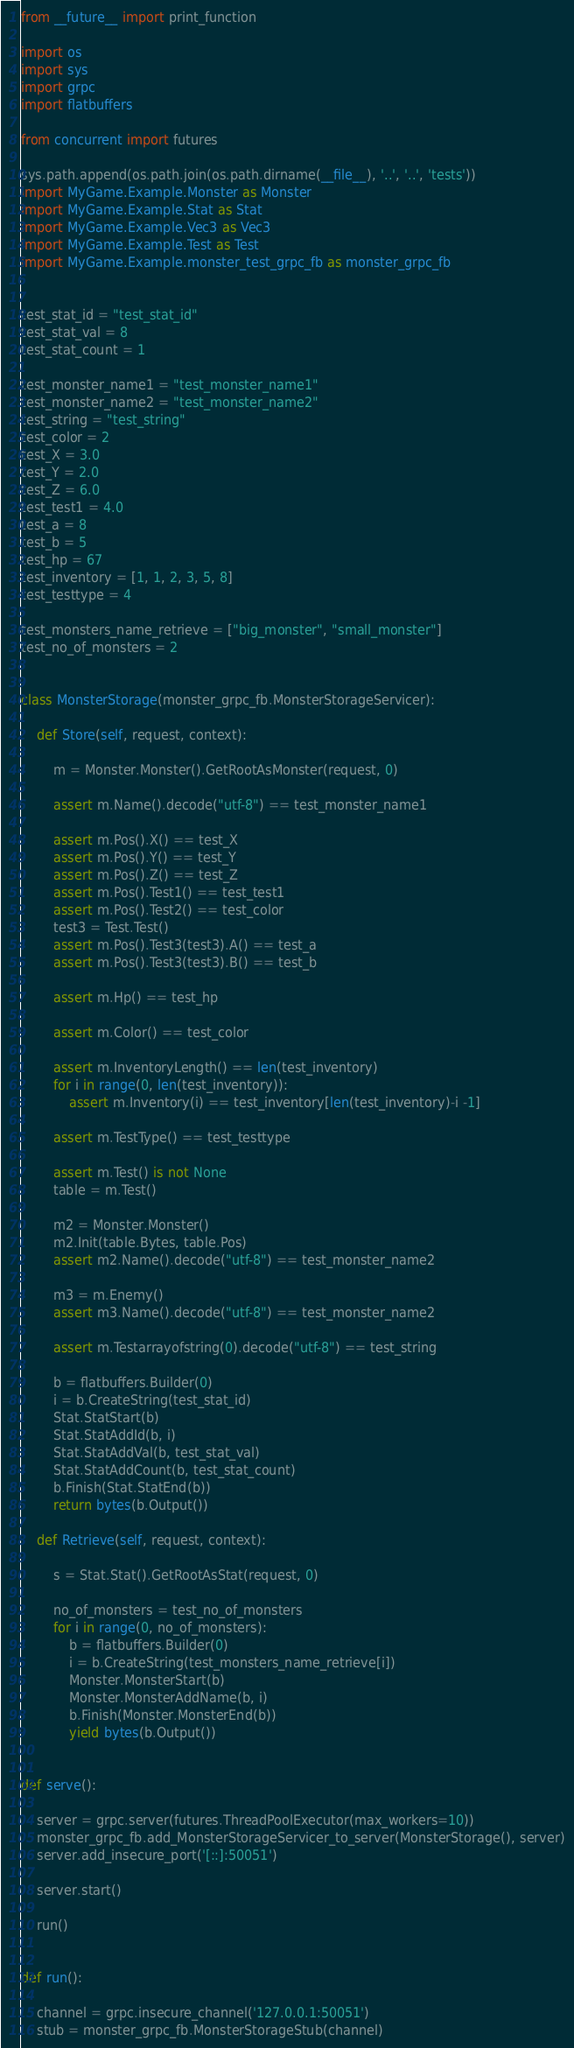Convert code to text. <code><loc_0><loc_0><loc_500><loc_500><_Python_>from __future__ import print_function

import os
import sys
import grpc
import flatbuffers

from concurrent import futures

sys.path.append(os.path.join(os.path.dirname(__file__), '..', '..', 'tests'))
import MyGame.Example.Monster as Monster
import MyGame.Example.Stat as Stat
import MyGame.Example.Vec3 as Vec3
import MyGame.Example.Test as Test
import MyGame.Example.monster_test_grpc_fb as monster_grpc_fb


test_stat_id = "test_stat_id"
test_stat_val = 8
test_stat_count = 1

test_monster_name1 = "test_monster_name1"
test_monster_name2 = "test_monster_name2"
test_string = "test_string"
test_color = 2
test_X = 3.0
test_Y = 2.0
test_Z = 6.0
test_test1 = 4.0
test_a = 8
test_b = 5
test_hp = 67
test_inventory = [1, 1, 2, 3, 5, 8]
test_testtype = 4

test_monsters_name_retrieve = ["big_monster", "small_monster"]
test_no_of_monsters = 2


class MonsterStorage(monster_grpc_fb.MonsterStorageServicer):

    def Store(self, request, context):

        m = Monster.Monster().GetRootAsMonster(request, 0)

        assert m.Name().decode("utf-8") == test_monster_name1

        assert m.Pos().X() == test_X
        assert m.Pos().Y() == test_Y
        assert m.Pos().Z() == test_Z
        assert m.Pos().Test1() == test_test1
        assert m.Pos().Test2() == test_color
        test3 = Test.Test()
        assert m.Pos().Test3(test3).A() == test_a
        assert m.Pos().Test3(test3).B() == test_b

        assert m.Hp() == test_hp

        assert m.Color() == test_color

        assert m.InventoryLength() == len(test_inventory)
        for i in range(0, len(test_inventory)):
            assert m.Inventory(i) == test_inventory[len(test_inventory)-i -1]

        assert m.TestType() == test_testtype

        assert m.Test() is not None
        table = m.Test()

        m2 = Monster.Monster()
        m2.Init(table.Bytes, table.Pos)
        assert m2.Name().decode("utf-8") == test_monster_name2

        m3 = m.Enemy()
        assert m3.Name().decode("utf-8") == test_monster_name2

        assert m.Testarrayofstring(0).decode("utf-8") == test_string

        b = flatbuffers.Builder(0)
        i = b.CreateString(test_stat_id)
        Stat.StatStart(b)
        Stat.StatAddId(b, i)
        Stat.StatAddVal(b, test_stat_val)
        Stat.StatAddCount(b, test_stat_count)
        b.Finish(Stat.StatEnd(b))
        return bytes(b.Output())

    def Retrieve(self, request, context):

        s = Stat.Stat().GetRootAsStat(request, 0)

        no_of_monsters = test_no_of_monsters
        for i in range(0, no_of_monsters):
            b = flatbuffers.Builder(0)
            i = b.CreateString(test_monsters_name_retrieve[i])
            Monster.MonsterStart(b)
            Monster.MonsterAddName(b, i)
            b.Finish(Monster.MonsterEnd(b))
            yield bytes(b.Output())


def serve():

    server = grpc.server(futures.ThreadPoolExecutor(max_workers=10))
    monster_grpc_fb.add_MonsterStorageServicer_to_server(MonsterStorage(), server)
    server.add_insecure_port('[::]:50051')

    server.start()

    run()


def run():

    channel = grpc.insecure_channel('127.0.0.1:50051')
    stub = monster_grpc_fb.MonsterStorageStub(channel)
</code> 